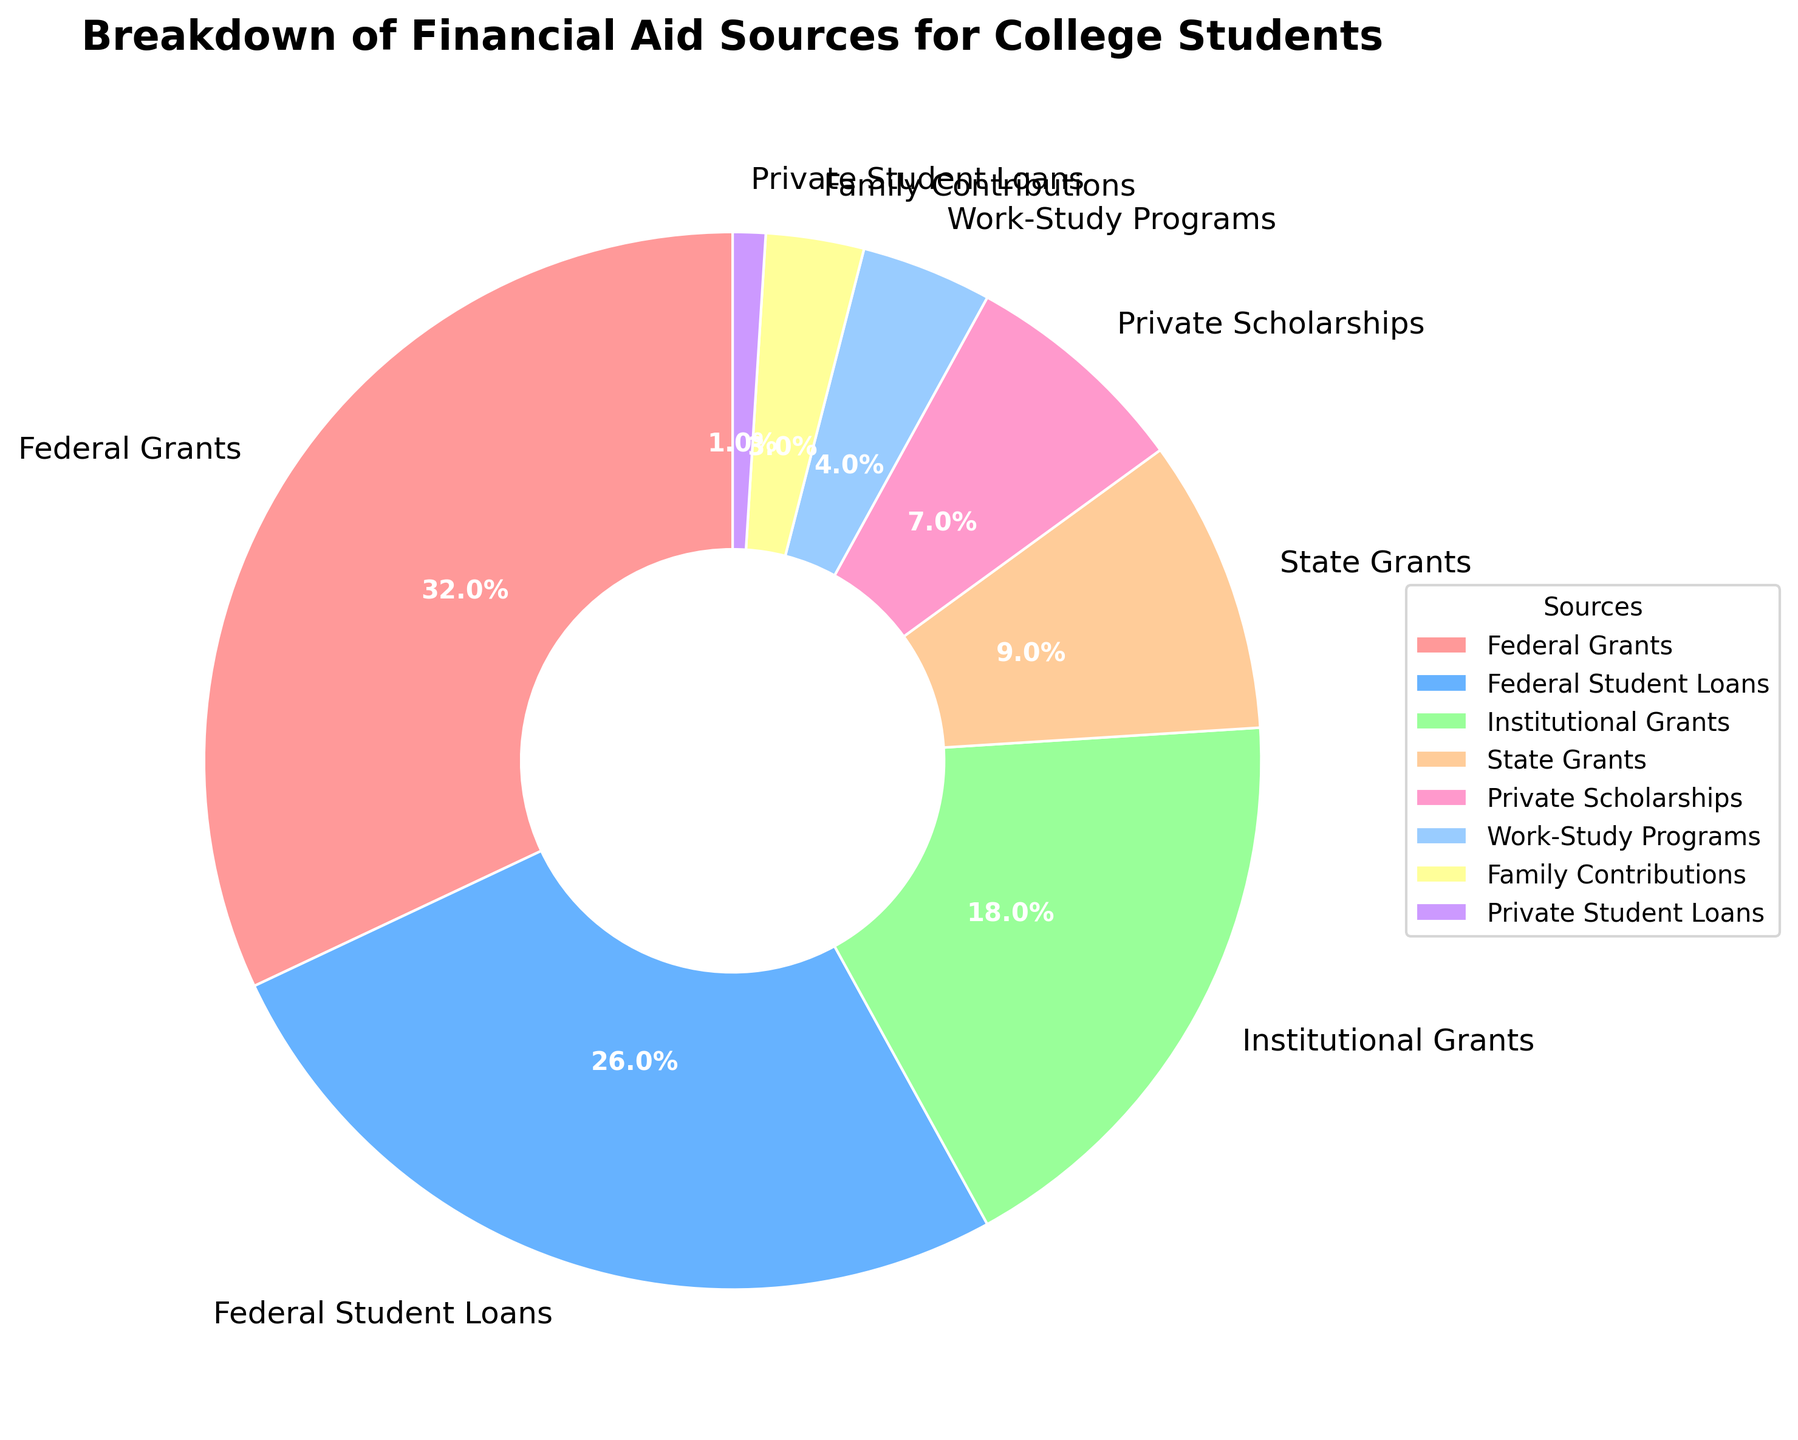What is the combined percentage of Federal Grants and Federal Student Loans? Federal Grants constitute 32% and Federal Student Loans constitute 26%. Adding these two percentages together gives 32% + 26% = 58%.
Answer: 58% Which financial aid source has the lowest percentage? By looking at the pie chart, we see that Private Student Loans have the lowest percentage at 1%.
Answer: Private Student Loans Which is larger in percentage, State Grants or Private Scholarships? The pie chart shows that State Grants are 9%, while Private Scholarships are 7%. Since 9% > 7%, State Grants have a larger percentage.
Answer: State Grants What is the total percentage of Institutional Grants, State Grants, and Private Scholarships combined? Institutional Grants are 18%, State Grants are 9%, and Private Scholarships are 7%. Adding these together gives 18% + 9% + 7% = 34%.
Answer: 34% Which color represents Work-Study Programs in the pie chart? The pie chart segment for Work-Study Programs is colored blue.
Answer: Blue How many financial aid sources make up more than 15% each of the total aid? Counting the segments larger than 15%: Federal Grants (32%) and Federal Student Loans (26%), and Institutional Grants (18%). There are three sources.
Answer: 3 Compare the sum of Family Contributions and Private Student Loans to the percentage of Federal Student Loans. Which is higher? Family Contributions are 3% and Private Student Loans are 1%, summing to 3% + 1% = 4%. Federal Student Loans are at 26%, which is higher than 4%.
Answer: Federal Student Loans Which financial aid source is closest in percentage to Work-Study Programs? Work-Study Programs are 4%, and the closest percentage to this is Family Contributions at 3%.
Answer: Family Contributions 